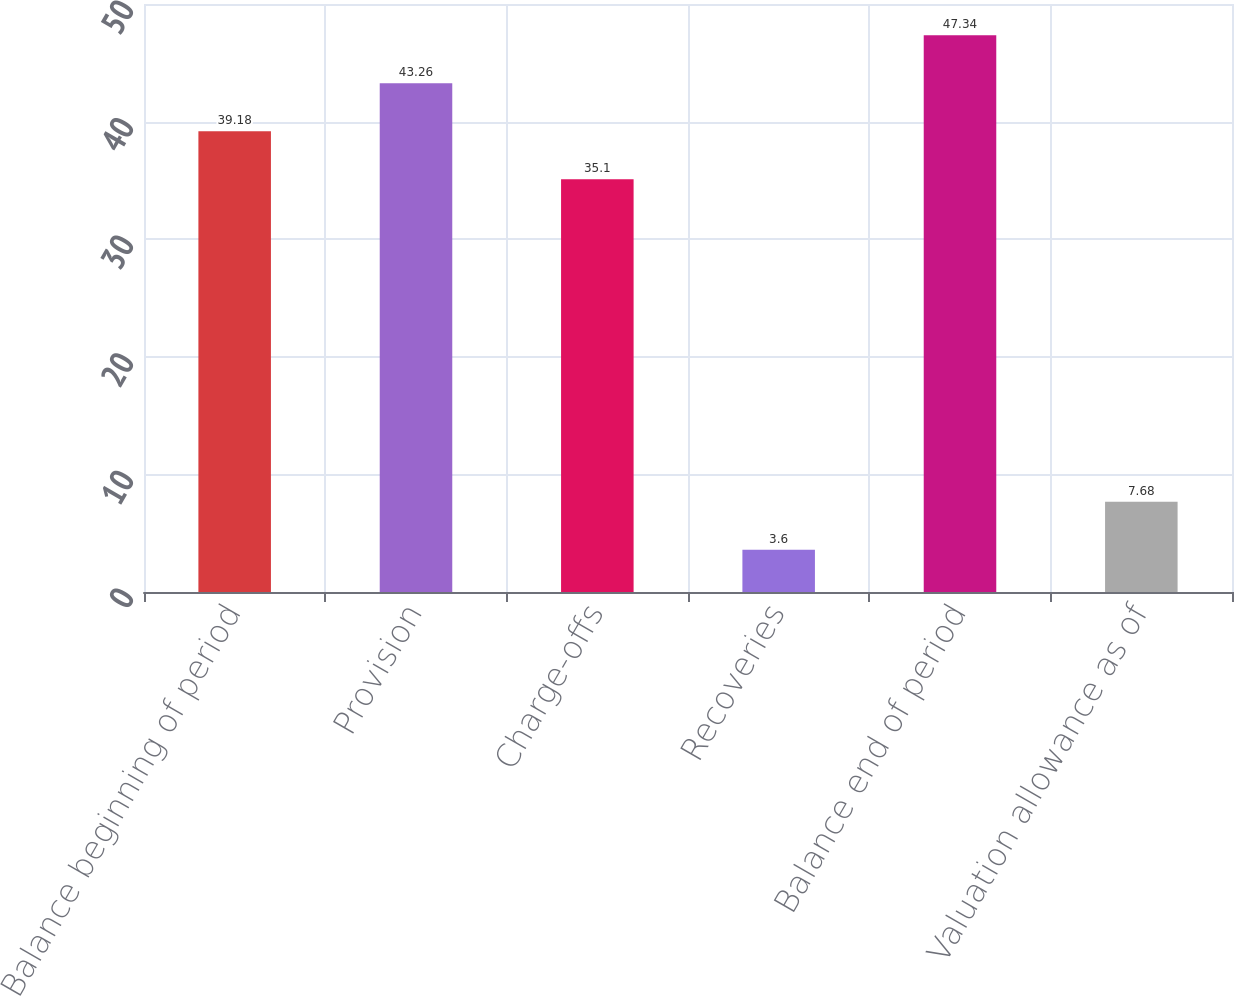<chart> <loc_0><loc_0><loc_500><loc_500><bar_chart><fcel>Balance beginning of period<fcel>Provision<fcel>Charge-offs<fcel>Recoveries<fcel>Balance end of period<fcel>Valuation allowance as of<nl><fcel>39.18<fcel>43.26<fcel>35.1<fcel>3.6<fcel>47.34<fcel>7.68<nl></chart> 